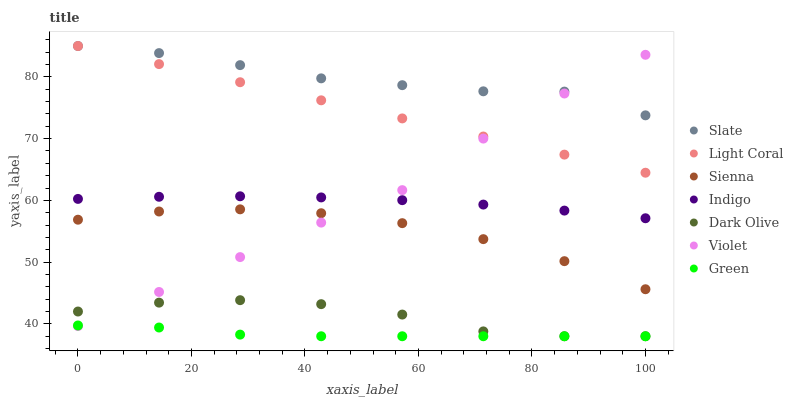Does Green have the minimum area under the curve?
Answer yes or no. Yes. Does Slate have the maximum area under the curve?
Answer yes or no. Yes. Does Indigo have the minimum area under the curve?
Answer yes or no. No. Does Indigo have the maximum area under the curve?
Answer yes or no. No. Is Light Coral the smoothest?
Answer yes or no. Yes. Is Dark Olive the roughest?
Answer yes or no. Yes. Is Indigo the smoothest?
Answer yes or no. No. Is Indigo the roughest?
Answer yes or no. No. Does Dark Olive have the lowest value?
Answer yes or no. Yes. Does Indigo have the lowest value?
Answer yes or no. No. Does Light Coral have the highest value?
Answer yes or no. Yes. Does Indigo have the highest value?
Answer yes or no. No. Is Dark Olive less than Slate?
Answer yes or no. Yes. Is Sienna greater than Green?
Answer yes or no. Yes. Does Indigo intersect Violet?
Answer yes or no. Yes. Is Indigo less than Violet?
Answer yes or no. No. Is Indigo greater than Violet?
Answer yes or no. No. Does Dark Olive intersect Slate?
Answer yes or no. No. 